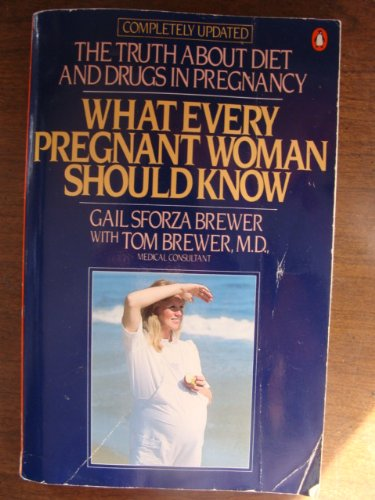What is the genre of this book? This book belongs to the 'Pregnancy & Childbirth' category within health and medical genres, focusing on the nutritional and medical needs of pregnant women. 